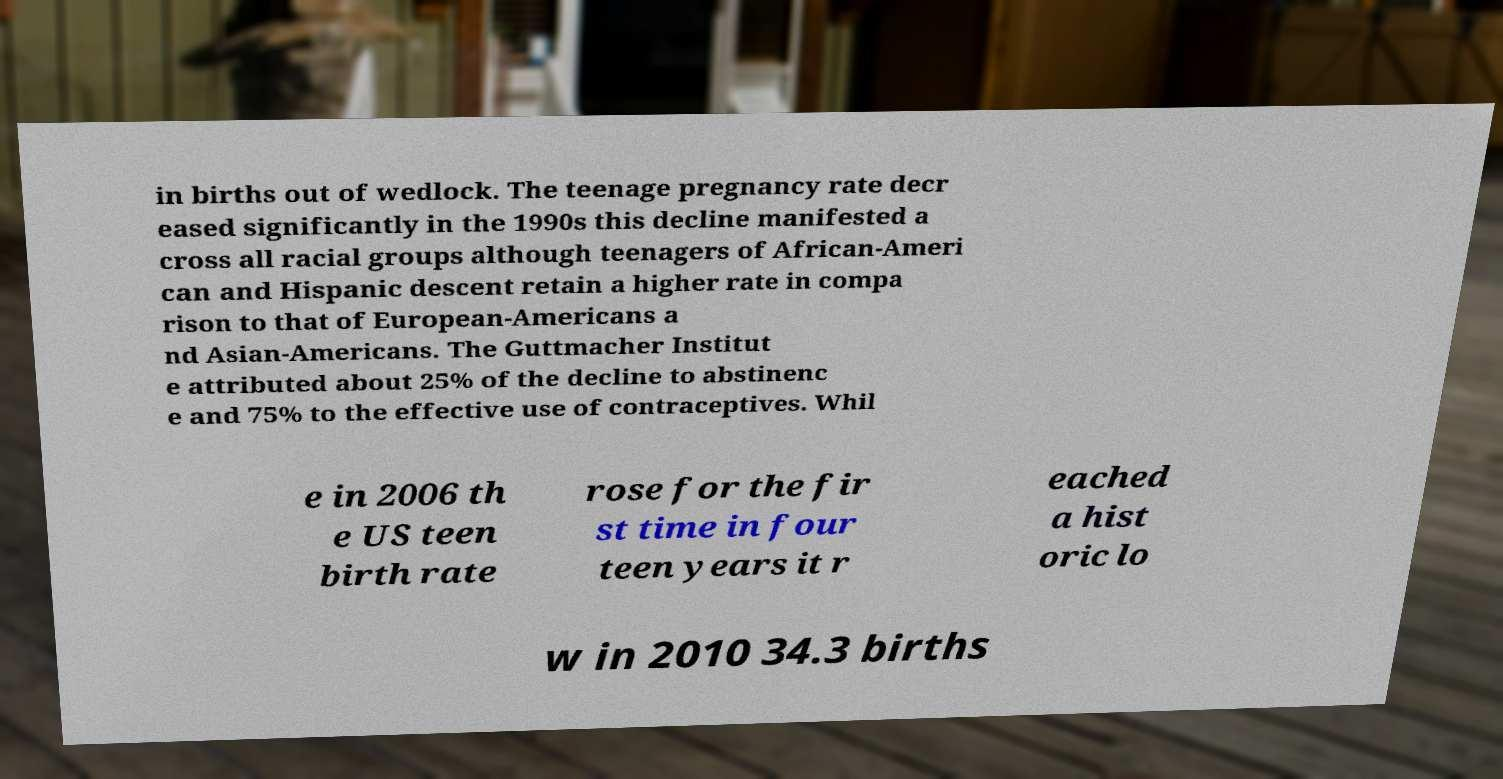Could you assist in decoding the text presented in this image and type it out clearly? in births out of wedlock. The teenage pregnancy rate decr eased significantly in the 1990s this decline manifested a cross all racial groups although teenagers of African-Ameri can and Hispanic descent retain a higher rate in compa rison to that of European-Americans a nd Asian-Americans. The Guttmacher Institut e attributed about 25% of the decline to abstinenc e and 75% to the effective use of contraceptives. Whil e in 2006 th e US teen birth rate rose for the fir st time in four teen years it r eached a hist oric lo w in 2010 34.3 births 